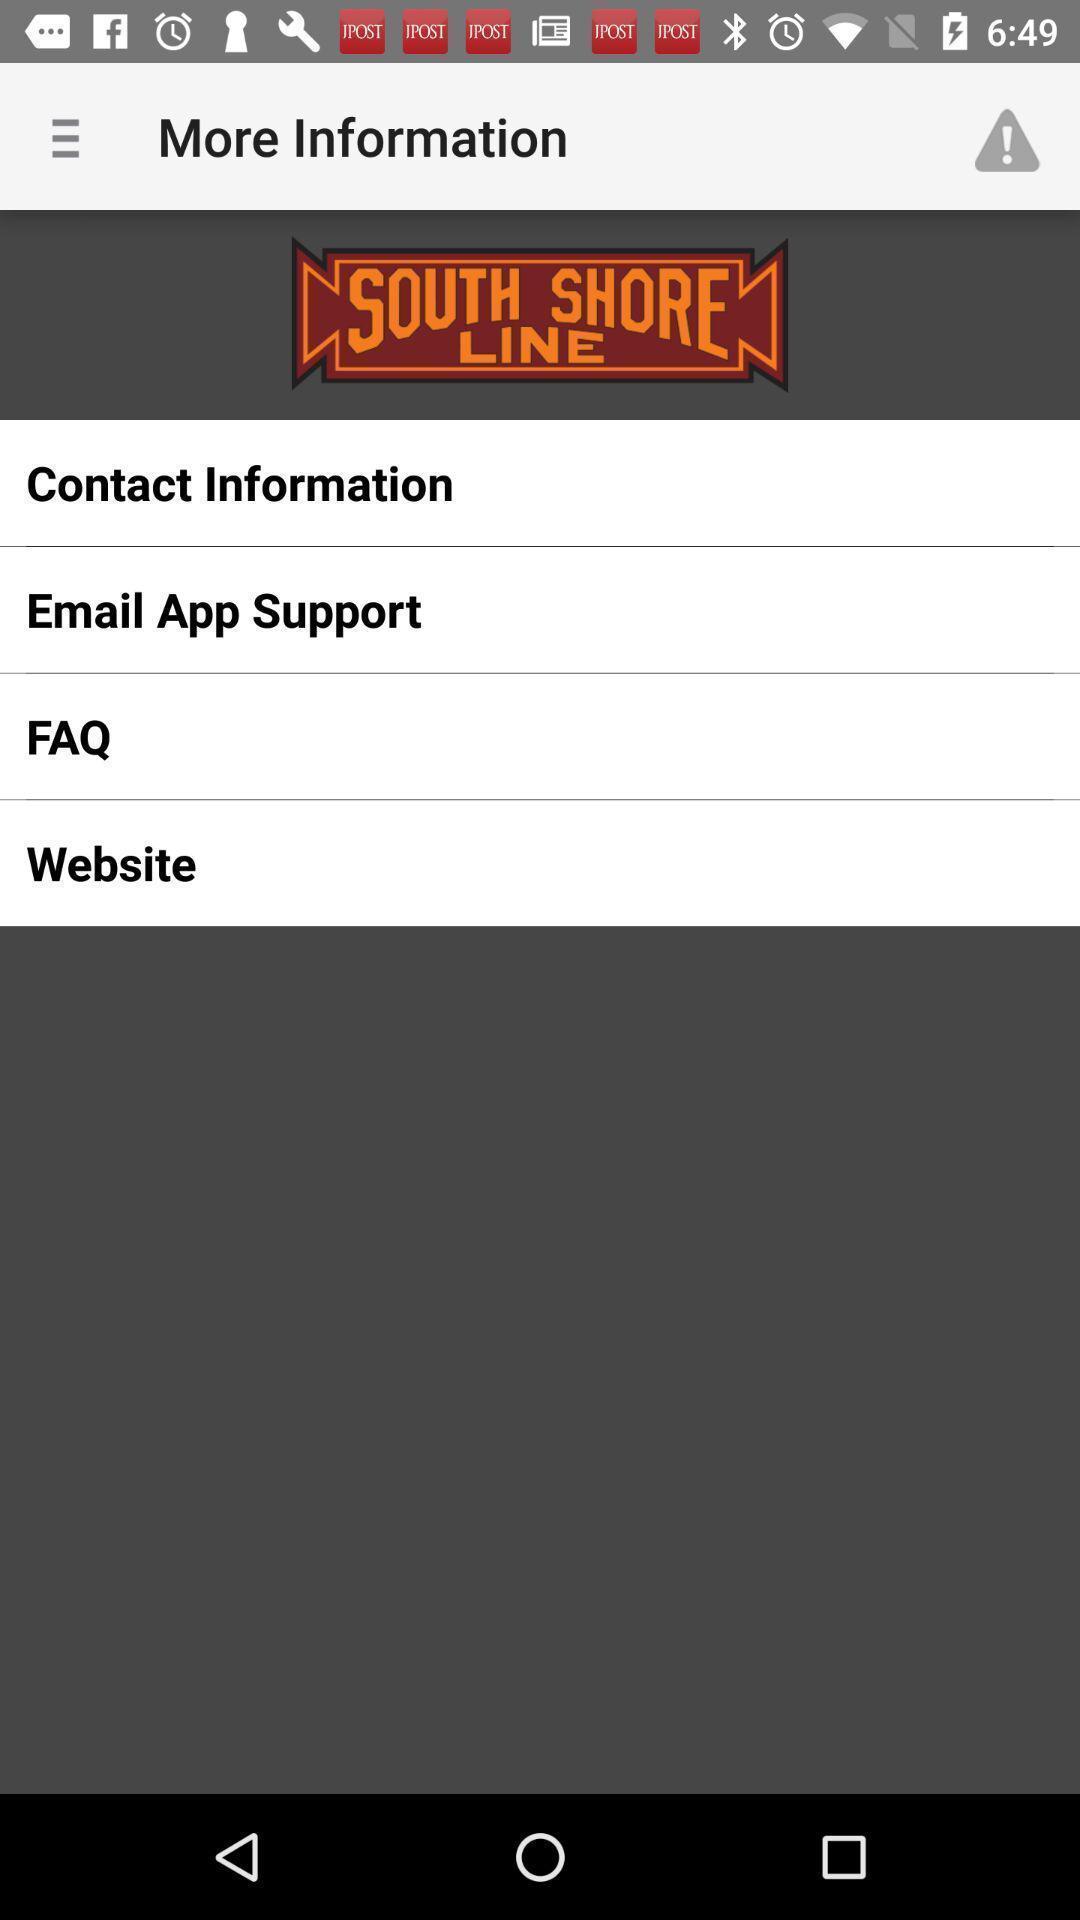Explain the elements present in this screenshot. Screen displaying the options in more information. 